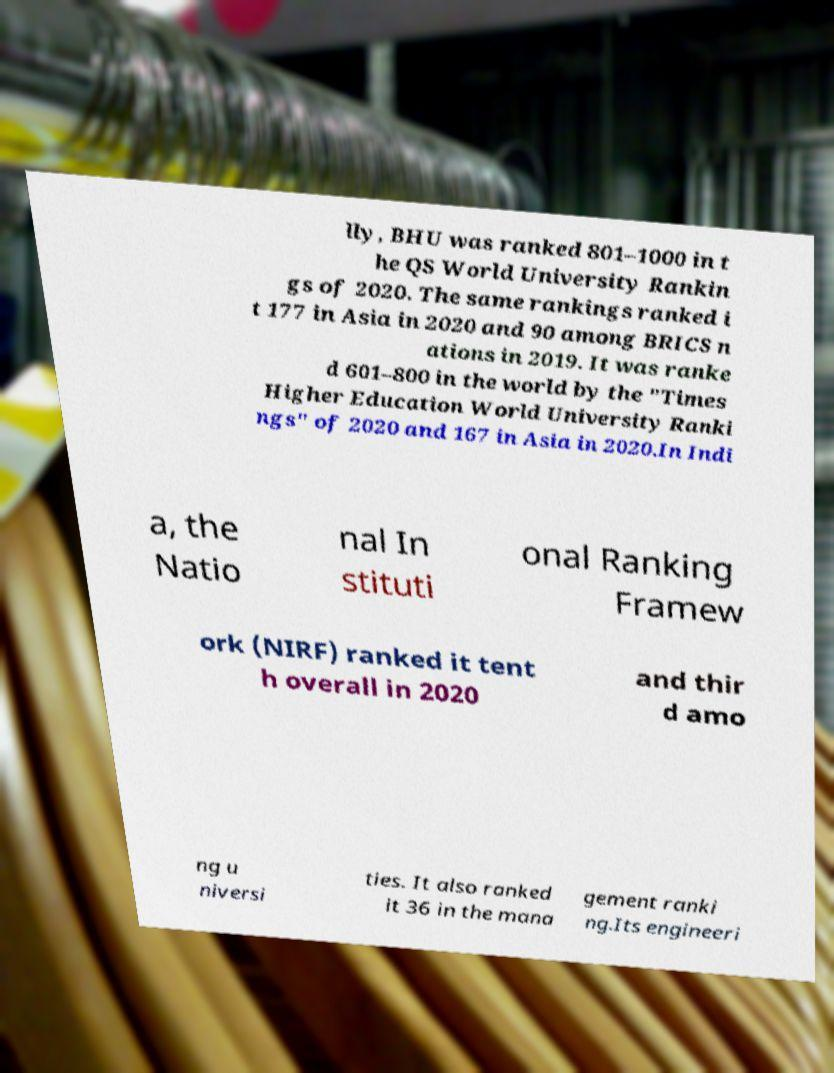I need the written content from this picture converted into text. Can you do that? lly, BHU was ranked 801–1000 in t he QS World University Rankin gs of 2020. The same rankings ranked i t 177 in Asia in 2020 and 90 among BRICS n ations in 2019. It was ranke d 601–800 in the world by the "Times Higher Education World University Ranki ngs" of 2020 and 167 in Asia in 2020.In Indi a, the Natio nal In stituti onal Ranking Framew ork (NIRF) ranked it tent h overall in 2020 and thir d amo ng u niversi ties. It also ranked it 36 in the mana gement ranki ng.Its engineeri 